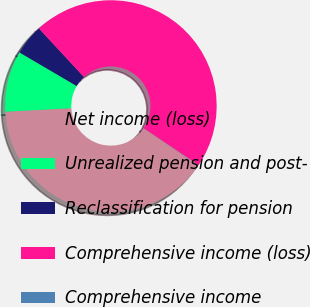Convert chart to OTSL. <chart><loc_0><loc_0><loc_500><loc_500><pie_chart><fcel>Net income (loss)<fcel>Unrealized pension and post-<fcel>Reclassification for pension<fcel>Comprehensive income (loss)<fcel>Comprehensive income<nl><fcel>39.69%<fcel>9.29%<fcel>4.66%<fcel>46.32%<fcel>0.03%<nl></chart> 